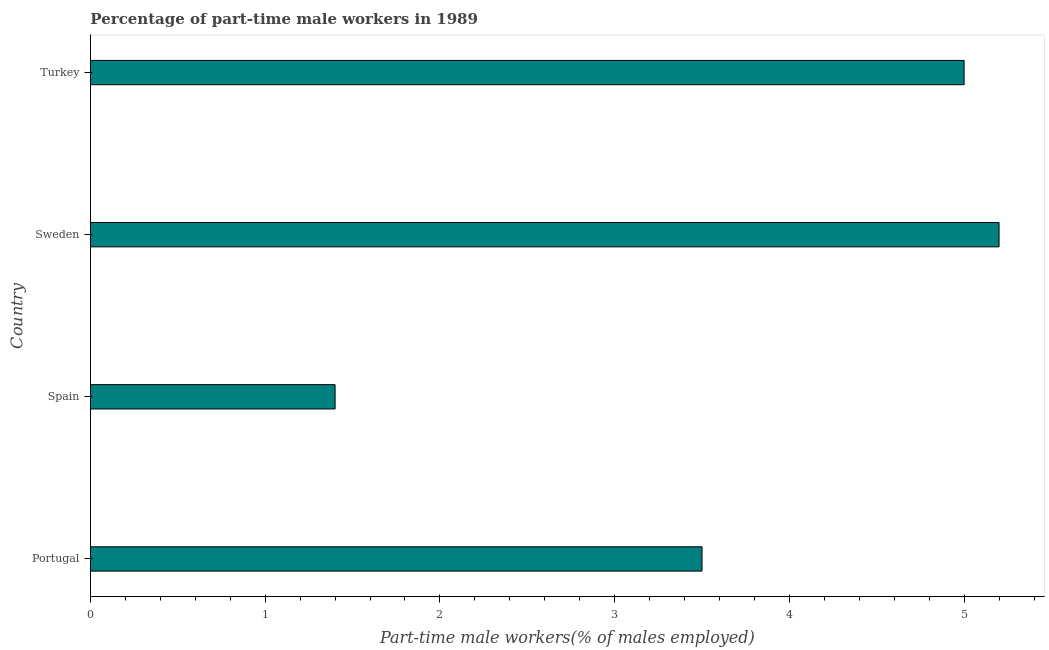Does the graph contain any zero values?
Your answer should be compact. No. Does the graph contain grids?
Your answer should be compact. No. What is the title of the graph?
Offer a terse response. Percentage of part-time male workers in 1989. What is the label or title of the X-axis?
Your answer should be compact. Part-time male workers(% of males employed). What is the percentage of part-time male workers in Spain?
Offer a very short reply. 1.4. Across all countries, what is the maximum percentage of part-time male workers?
Give a very brief answer. 5.2. Across all countries, what is the minimum percentage of part-time male workers?
Your answer should be very brief. 1.4. In which country was the percentage of part-time male workers maximum?
Your answer should be very brief. Sweden. What is the sum of the percentage of part-time male workers?
Offer a very short reply. 15.1. What is the difference between the percentage of part-time male workers in Sweden and Turkey?
Your answer should be compact. 0.2. What is the average percentage of part-time male workers per country?
Your answer should be very brief. 3.77. What is the median percentage of part-time male workers?
Provide a short and direct response. 4.25. What is the ratio of the percentage of part-time male workers in Spain to that in Turkey?
Offer a very short reply. 0.28. What is the difference between the highest and the lowest percentage of part-time male workers?
Your answer should be very brief. 3.8. In how many countries, is the percentage of part-time male workers greater than the average percentage of part-time male workers taken over all countries?
Keep it short and to the point. 2. How many bars are there?
Make the answer very short. 4. Are all the bars in the graph horizontal?
Your response must be concise. Yes. What is the difference between two consecutive major ticks on the X-axis?
Your answer should be compact. 1. Are the values on the major ticks of X-axis written in scientific E-notation?
Provide a succinct answer. No. What is the Part-time male workers(% of males employed) of Portugal?
Provide a succinct answer. 3.5. What is the Part-time male workers(% of males employed) in Spain?
Your response must be concise. 1.4. What is the Part-time male workers(% of males employed) in Sweden?
Offer a terse response. 5.2. What is the difference between the Part-time male workers(% of males employed) in Portugal and Spain?
Give a very brief answer. 2.1. What is the ratio of the Part-time male workers(% of males employed) in Portugal to that in Sweden?
Provide a succinct answer. 0.67. What is the ratio of the Part-time male workers(% of males employed) in Spain to that in Sweden?
Give a very brief answer. 0.27. What is the ratio of the Part-time male workers(% of males employed) in Spain to that in Turkey?
Offer a terse response. 0.28. 